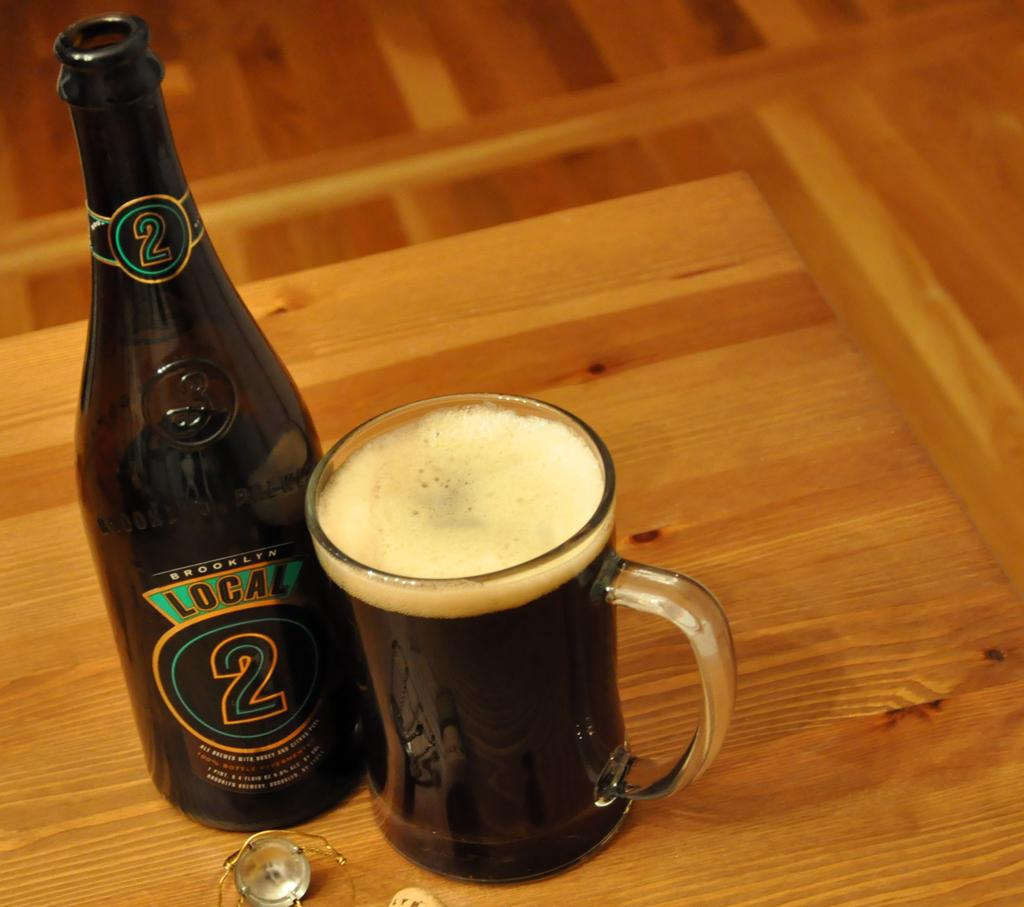<image>
Create a compact narrative representing the image presented. A full glass next to a bottle of Local 2 beverage 